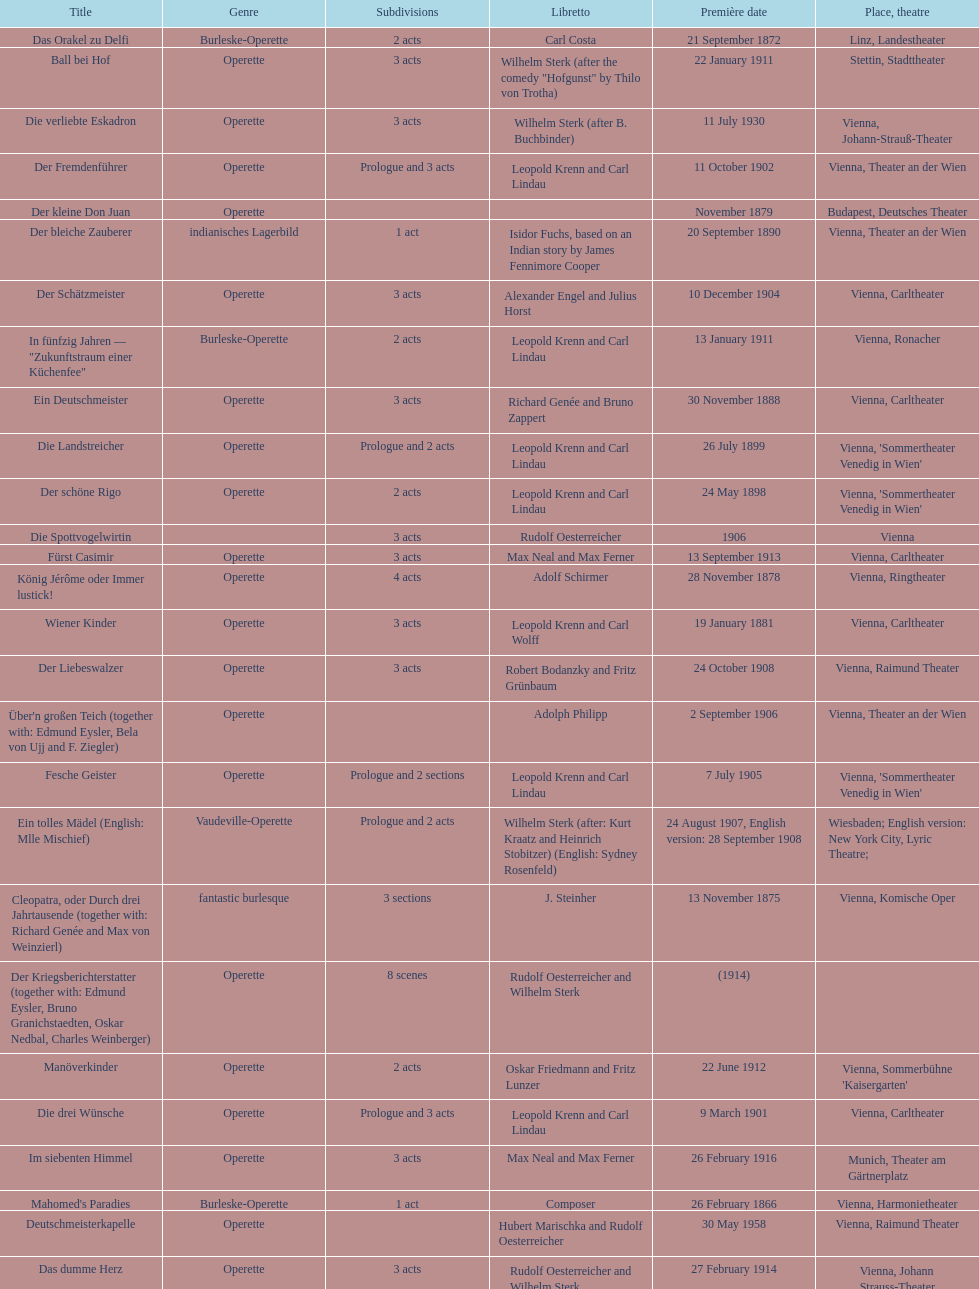In which city did the most operettas premiere? Vienna. 